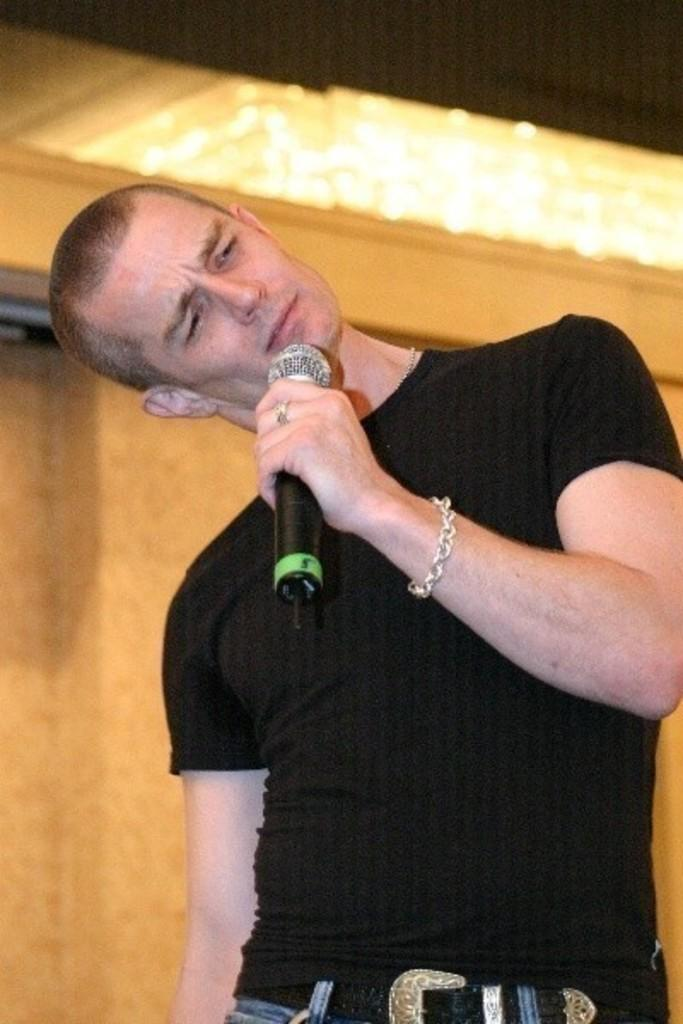What is the main subject of the image? There is a person in the image. What is the person wearing? The person is wearing a black T-shirt. What object is the person holding? The person is carrying a microphone. Can you describe any accessories the person is wearing? The person has a bracelet on their hand. What can be seen in the background of the image? There is a wall in the background of the image. What type of shoes is the person wearing in the image? The provided facts do not mention any shoes, so we cannot determine the type of shoes the person is wearing. 